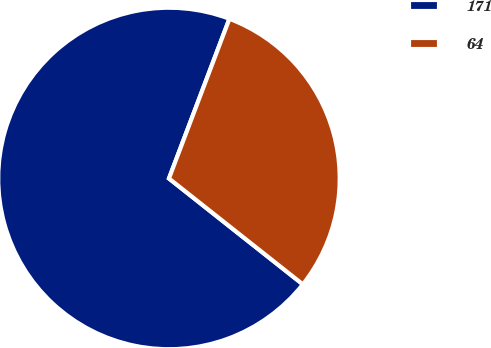Convert chart to OTSL. <chart><loc_0><loc_0><loc_500><loc_500><pie_chart><fcel>171<fcel>64<nl><fcel>70.11%<fcel>29.89%<nl></chart> 